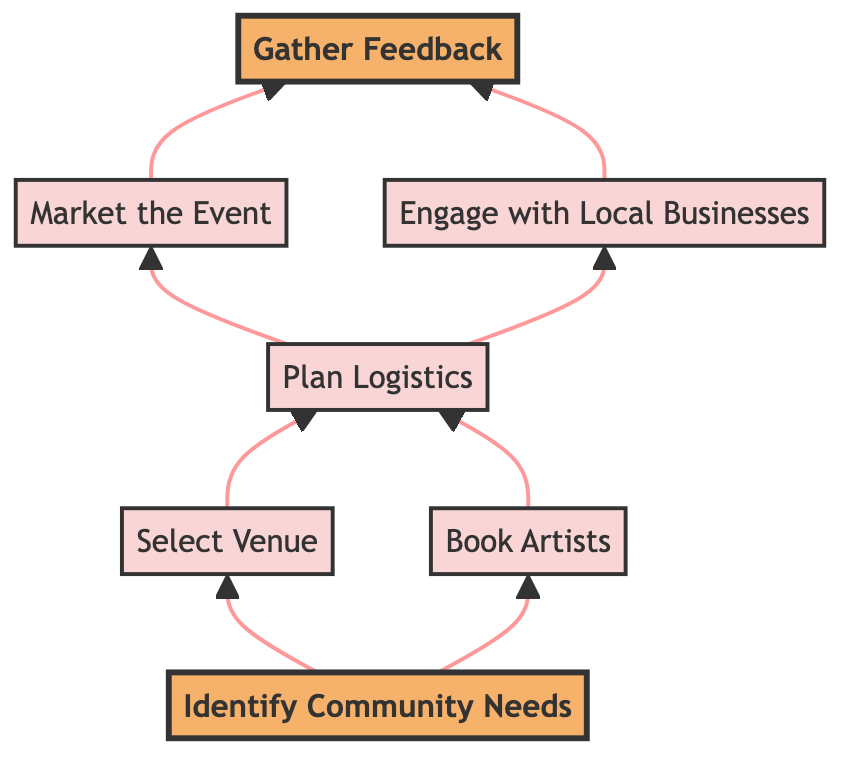What is the first step in planning the event? The first step is labeled "Identify Community Needs." It is positioned at the top of the diagram and is the starting point of the flow.
Answer: Identify Community Needs How many total steps are there in this flow chart? The diagram contains a total of seven steps, as there are seven distinct nodes listed in the flowchart.
Answer: Seven Which step follows after "Select Venue"? The step that follows "Select Venue" is "Plan Logistics." This can be determined by directly looking at the arrows representing the flow direction from "Select Venue."
Answer: Plan Logistics What two steps occur after "Plan Logistics"? The two steps that occur after "Plan Logistics" are "Market the Event" and "Engage with Local Businesses," both of which are connected to "Plan Logistics" through arrows.
Answer: Market the Event and Engage with Local Businesses Which step is highlighted in the diagram? The steps highlighted are "Identify Community Needs" and "Gather Feedback," indicated by their bold style and distinct fill color, which denotes their importance in the flow.
Answer: Identify Community Needs and Gather Feedback What is the final step in the event planning process? The final step in the process is "Gather Feedback," which is the last node connected from "Market the Event" and "Engage with Local Businesses."
Answer: Gather Feedback What are the two main activities that follow after selecting a venue? The two main activities that follow "Select Venue" are "Plan Logistics" and "Book Artists," both of which are directly linked to "Select Venue."
Answer: Plan Logistics and Book Artists How is feedback gathered after the event? Feedback is gathered through "Post-event surveys and discussions," which is described in the "Gather Feedback" step as a method for collecting insights.
Answer: Post-event surveys and discussions Which node has the most connections to other steps? The node with the most connections is "Plan Logistics," as it has two outgoing edges leading to "Market the Event" and "Engage with Local Businesses."
Answer: Plan Logistics 